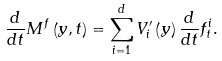Convert formula to latex. <formula><loc_0><loc_0><loc_500><loc_500>\frac { d } { d t } M ^ { f } \left ( y , t \right ) = \sum _ { i = 1 } ^ { d } V _ { i } ^ { \prime } \left ( y \right ) \frac { d } { d t } f _ { t } ^ { i } .</formula> 